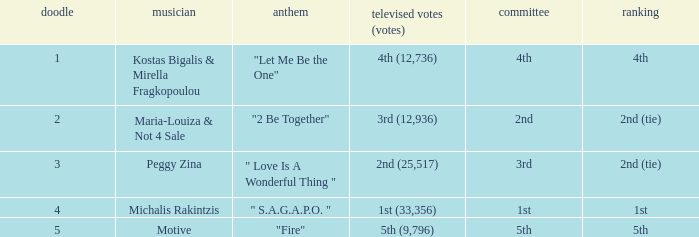What is the greatest draw that has 4th for place? 1.0. 